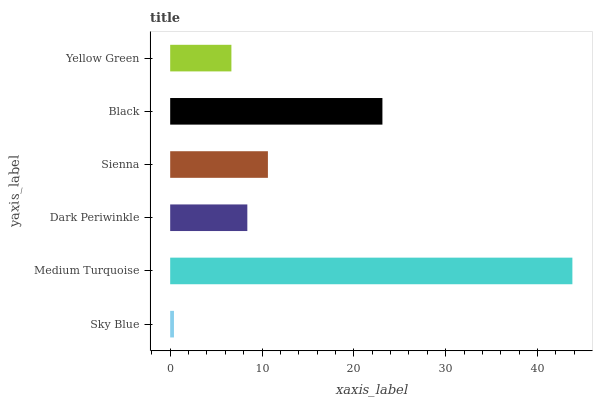Is Sky Blue the minimum?
Answer yes or no. Yes. Is Medium Turquoise the maximum?
Answer yes or no. Yes. Is Dark Periwinkle the minimum?
Answer yes or no. No. Is Dark Periwinkle the maximum?
Answer yes or no. No. Is Medium Turquoise greater than Dark Periwinkle?
Answer yes or no. Yes. Is Dark Periwinkle less than Medium Turquoise?
Answer yes or no. Yes. Is Dark Periwinkle greater than Medium Turquoise?
Answer yes or no. No. Is Medium Turquoise less than Dark Periwinkle?
Answer yes or no. No. Is Sienna the high median?
Answer yes or no. Yes. Is Dark Periwinkle the low median?
Answer yes or no. Yes. Is Medium Turquoise the high median?
Answer yes or no. No. Is Yellow Green the low median?
Answer yes or no. No. 